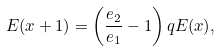<formula> <loc_0><loc_0><loc_500><loc_500>E ( x + 1 ) = \left ( \frac { e _ { 2 } } { e _ { 1 } } - 1 \right ) q E ( x ) ,</formula> 